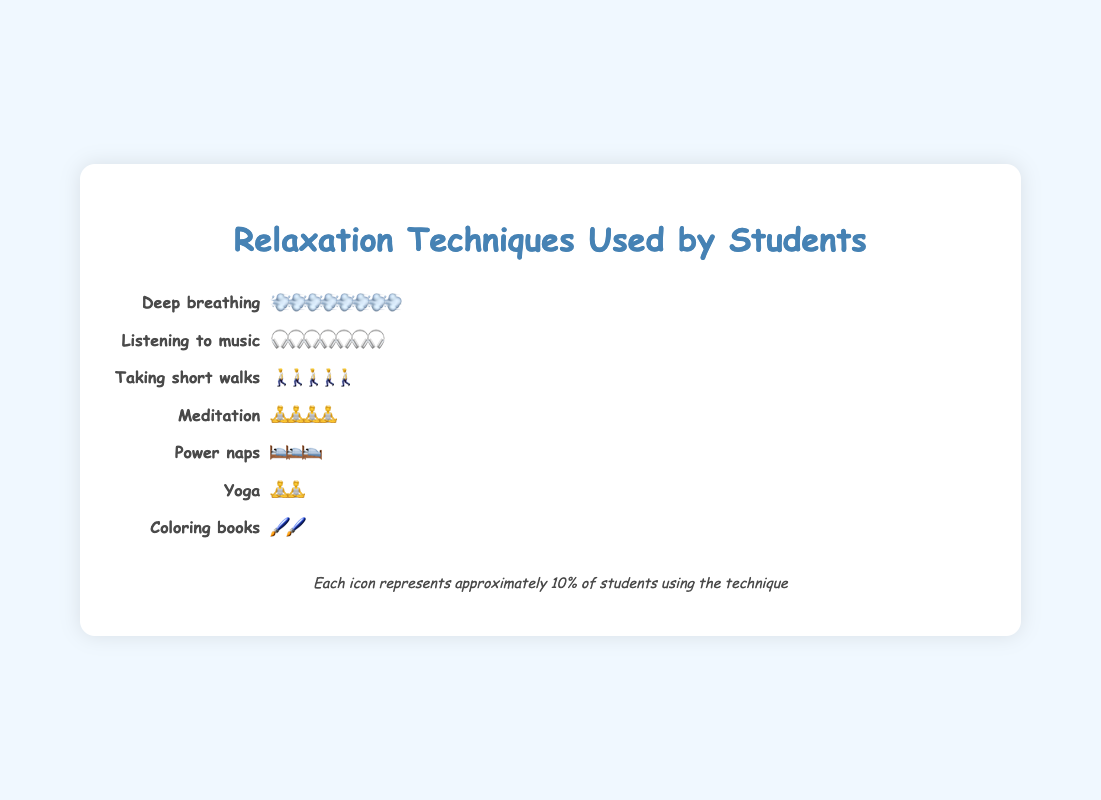What is the most frequently used relaxation technique? By looking at the icons and their frequency, the technique with the most icons is "Deep breathing," which has 8 lung icons.
Answer: Deep breathing How many students use yoga as a relaxation technique? Each icon represents approximately 10% of students. "Yoga" has 2 icons, so 2 icons * 10 = 20% of students.
Answer: 20 Which technique is used more: Meditation or Power naps? Meditation has 4 icons, while Power naps has 3 icons. Therefore, Meditation is used more than Power naps.
Answer: Meditation How many techniques have a frequency of 50% or more? By counting the techniques with 5 or more icons: Deep breathing (8 icons), Listening to music (6.5 icons), and Taking short walks (5 icons).
Answer: 3 What percentage of students use Coloring books? Coloring books have 1.5 icons, and since each icon represents approximately 10% of students: 1.5 icons * 10 = 15% of students.
Answer: 15 What's the combined percentage of students using Power naps and Yoga? Power naps have 3 icons, and Yoga has 2 icons. Combining them: (3 + 2) icons * 10% = 50%.
Answer: 50% Which relaxation technique has the least number of users? The technique with the least icons is "Coloring books," which has 1.5 icons.
Answer: Coloring books How many more students use Deep breathing compared to Meditation? Deep breathing has 8 icons, and Meditation has 4 icons. The difference is (8 - 4) * 10% = 40%.
Answer: 40 How many relaxation techniques are represented in the plot? By counting the number of techniques listed: Deep breathing, Listening to music, Taking short walks, Meditation, Yoga, Power naps, and Coloring books.
Answer: 7 Is there a technique that exactly 35% of students use? The plot indicates that Meditation has 3.5 icons, representing exactly 35% of students.
Answer: Yes, Meditation 